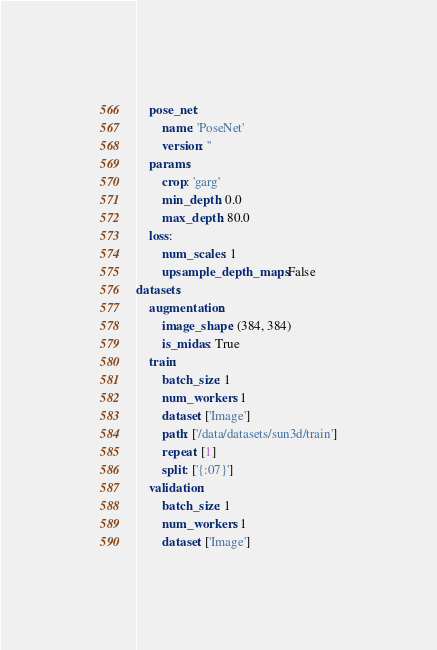<code> <loc_0><loc_0><loc_500><loc_500><_YAML_>    pose_net:
        name: 'PoseNet'
        version: ''
    params:
        crop: 'garg'
        min_depth: 0.0
        max_depth: 80.0
    loss:
        num_scales: 1
        upsample_depth_maps: False
datasets:
    augmentation:
        image_shape: (384, 384)
        is_midas: True
    train:
        batch_size: 1
        num_workers: 1
        dataset: ['Image']
        path: ['/data/datasets/sun3d/train']
        repeat: [1]
        split: ['{:07}']
    validation:
        batch_size: 1
        num_workers: 1
        dataset: ['Image']</code> 